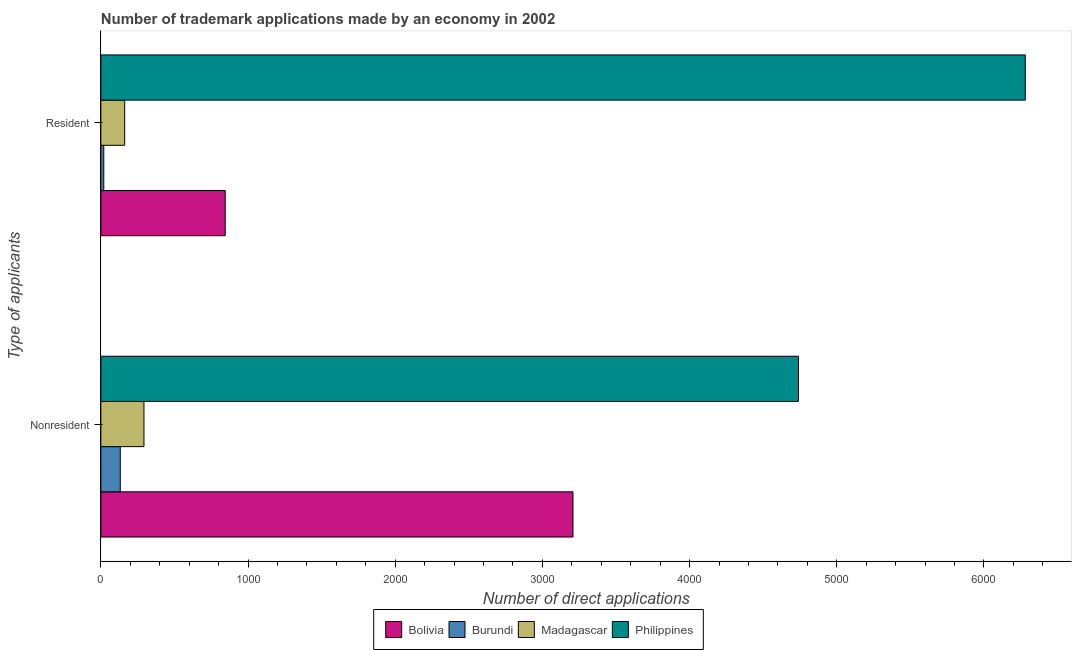How many different coloured bars are there?
Your answer should be very brief. 4. How many groups of bars are there?
Make the answer very short. 2. How many bars are there on the 2nd tick from the top?
Your answer should be very brief. 4. What is the label of the 2nd group of bars from the top?
Provide a short and direct response. Nonresident. What is the number of trademark applications made by residents in Madagascar?
Provide a short and direct response. 162. Across all countries, what is the maximum number of trademark applications made by residents?
Your response must be concise. 6281. Across all countries, what is the minimum number of trademark applications made by residents?
Make the answer very short. 20. In which country was the number of trademark applications made by residents maximum?
Offer a terse response. Philippines. In which country was the number of trademark applications made by non residents minimum?
Give a very brief answer. Burundi. What is the total number of trademark applications made by residents in the graph?
Your answer should be compact. 7308. What is the difference between the number of trademark applications made by residents in Bolivia and that in Burundi?
Your answer should be very brief. 825. What is the difference between the number of trademark applications made by non residents in Madagascar and the number of trademark applications made by residents in Burundi?
Your answer should be very brief. 273. What is the average number of trademark applications made by residents per country?
Offer a very short reply. 1827. What is the difference between the number of trademark applications made by non residents and number of trademark applications made by residents in Madagascar?
Provide a short and direct response. 131. What is the ratio of the number of trademark applications made by residents in Burundi to that in Philippines?
Provide a short and direct response. 0. Is the number of trademark applications made by residents in Bolivia less than that in Philippines?
Keep it short and to the point. Yes. What does the 3rd bar from the top in Nonresident represents?
Ensure brevity in your answer.  Burundi. What is the difference between two consecutive major ticks on the X-axis?
Ensure brevity in your answer.  1000. Does the graph contain grids?
Provide a short and direct response. No. Where does the legend appear in the graph?
Your response must be concise. Bottom center. How many legend labels are there?
Your answer should be compact. 4. What is the title of the graph?
Give a very brief answer. Number of trademark applications made by an economy in 2002. What is the label or title of the X-axis?
Keep it short and to the point. Number of direct applications. What is the label or title of the Y-axis?
Ensure brevity in your answer.  Type of applicants. What is the Number of direct applications in Bolivia in Nonresident?
Provide a short and direct response. 3208. What is the Number of direct applications in Burundi in Nonresident?
Offer a terse response. 132. What is the Number of direct applications in Madagascar in Nonresident?
Your response must be concise. 293. What is the Number of direct applications in Philippines in Nonresident?
Your answer should be very brief. 4740. What is the Number of direct applications of Bolivia in Resident?
Keep it short and to the point. 845. What is the Number of direct applications of Madagascar in Resident?
Your answer should be compact. 162. What is the Number of direct applications of Philippines in Resident?
Make the answer very short. 6281. Across all Type of applicants, what is the maximum Number of direct applications of Bolivia?
Provide a succinct answer. 3208. Across all Type of applicants, what is the maximum Number of direct applications in Burundi?
Provide a succinct answer. 132. Across all Type of applicants, what is the maximum Number of direct applications in Madagascar?
Your response must be concise. 293. Across all Type of applicants, what is the maximum Number of direct applications of Philippines?
Keep it short and to the point. 6281. Across all Type of applicants, what is the minimum Number of direct applications of Bolivia?
Your response must be concise. 845. Across all Type of applicants, what is the minimum Number of direct applications in Burundi?
Provide a succinct answer. 20. Across all Type of applicants, what is the minimum Number of direct applications of Madagascar?
Your answer should be very brief. 162. Across all Type of applicants, what is the minimum Number of direct applications of Philippines?
Give a very brief answer. 4740. What is the total Number of direct applications of Bolivia in the graph?
Provide a succinct answer. 4053. What is the total Number of direct applications of Burundi in the graph?
Ensure brevity in your answer.  152. What is the total Number of direct applications in Madagascar in the graph?
Your answer should be compact. 455. What is the total Number of direct applications of Philippines in the graph?
Provide a short and direct response. 1.10e+04. What is the difference between the Number of direct applications of Bolivia in Nonresident and that in Resident?
Provide a succinct answer. 2363. What is the difference between the Number of direct applications in Burundi in Nonresident and that in Resident?
Provide a succinct answer. 112. What is the difference between the Number of direct applications in Madagascar in Nonresident and that in Resident?
Give a very brief answer. 131. What is the difference between the Number of direct applications in Philippines in Nonresident and that in Resident?
Make the answer very short. -1541. What is the difference between the Number of direct applications in Bolivia in Nonresident and the Number of direct applications in Burundi in Resident?
Keep it short and to the point. 3188. What is the difference between the Number of direct applications of Bolivia in Nonresident and the Number of direct applications of Madagascar in Resident?
Your response must be concise. 3046. What is the difference between the Number of direct applications of Bolivia in Nonresident and the Number of direct applications of Philippines in Resident?
Give a very brief answer. -3073. What is the difference between the Number of direct applications of Burundi in Nonresident and the Number of direct applications of Madagascar in Resident?
Ensure brevity in your answer.  -30. What is the difference between the Number of direct applications in Burundi in Nonresident and the Number of direct applications in Philippines in Resident?
Provide a succinct answer. -6149. What is the difference between the Number of direct applications in Madagascar in Nonresident and the Number of direct applications in Philippines in Resident?
Give a very brief answer. -5988. What is the average Number of direct applications in Bolivia per Type of applicants?
Offer a very short reply. 2026.5. What is the average Number of direct applications of Madagascar per Type of applicants?
Make the answer very short. 227.5. What is the average Number of direct applications in Philippines per Type of applicants?
Provide a succinct answer. 5510.5. What is the difference between the Number of direct applications in Bolivia and Number of direct applications in Burundi in Nonresident?
Offer a very short reply. 3076. What is the difference between the Number of direct applications in Bolivia and Number of direct applications in Madagascar in Nonresident?
Your answer should be compact. 2915. What is the difference between the Number of direct applications in Bolivia and Number of direct applications in Philippines in Nonresident?
Give a very brief answer. -1532. What is the difference between the Number of direct applications of Burundi and Number of direct applications of Madagascar in Nonresident?
Your response must be concise. -161. What is the difference between the Number of direct applications in Burundi and Number of direct applications in Philippines in Nonresident?
Offer a terse response. -4608. What is the difference between the Number of direct applications in Madagascar and Number of direct applications in Philippines in Nonresident?
Ensure brevity in your answer.  -4447. What is the difference between the Number of direct applications in Bolivia and Number of direct applications in Burundi in Resident?
Your answer should be compact. 825. What is the difference between the Number of direct applications in Bolivia and Number of direct applications in Madagascar in Resident?
Make the answer very short. 683. What is the difference between the Number of direct applications of Bolivia and Number of direct applications of Philippines in Resident?
Offer a very short reply. -5436. What is the difference between the Number of direct applications in Burundi and Number of direct applications in Madagascar in Resident?
Make the answer very short. -142. What is the difference between the Number of direct applications in Burundi and Number of direct applications in Philippines in Resident?
Your answer should be very brief. -6261. What is the difference between the Number of direct applications in Madagascar and Number of direct applications in Philippines in Resident?
Give a very brief answer. -6119. What is the ratio of the Number of direct applications of Bolivia in Nonresident to that in Resident?
Ensure brevity in your answer.  3.8. What is the ratio of the Number of direct applications of Madagascar in Nonresident to that in Resident?
Provide a short and direct response. 1.81. What is the ratio of the Number of direct applications in Philippines in Nonresident to that in Resident?
Your answer should be compact. 0.75. What is the difference between the highest and the second highest Number of direct applications of Bolivia?
Offer a terse response. 2363. What is the difference between the highest and the second highest Number of direct applications in Burundi?
Provide a short and direct response. 112. What is the difference between the highest and the second highest Number of direct applications in Madagascar?
Ensure brevity in your answer.  131. What is the difference between the highest and the second highest Number of direct applications of Philippines?
Provide a short and direct response. 1541. What is the difference between the highest and the lowest Number of direct applications in Bolivia?
Give a very brief answer. 2363. What is the difference between the highest and the lowest Number of direct applications in Burundi?
Your answer should be compact. 112. What is the difference between the highest and the lowest Number of direct applications of Madagascar?
Provide a short and direct response. 131. What is the difference between the highest and the lowest Number of direct applications in Philippines?
Offer a terse response. 1541. 